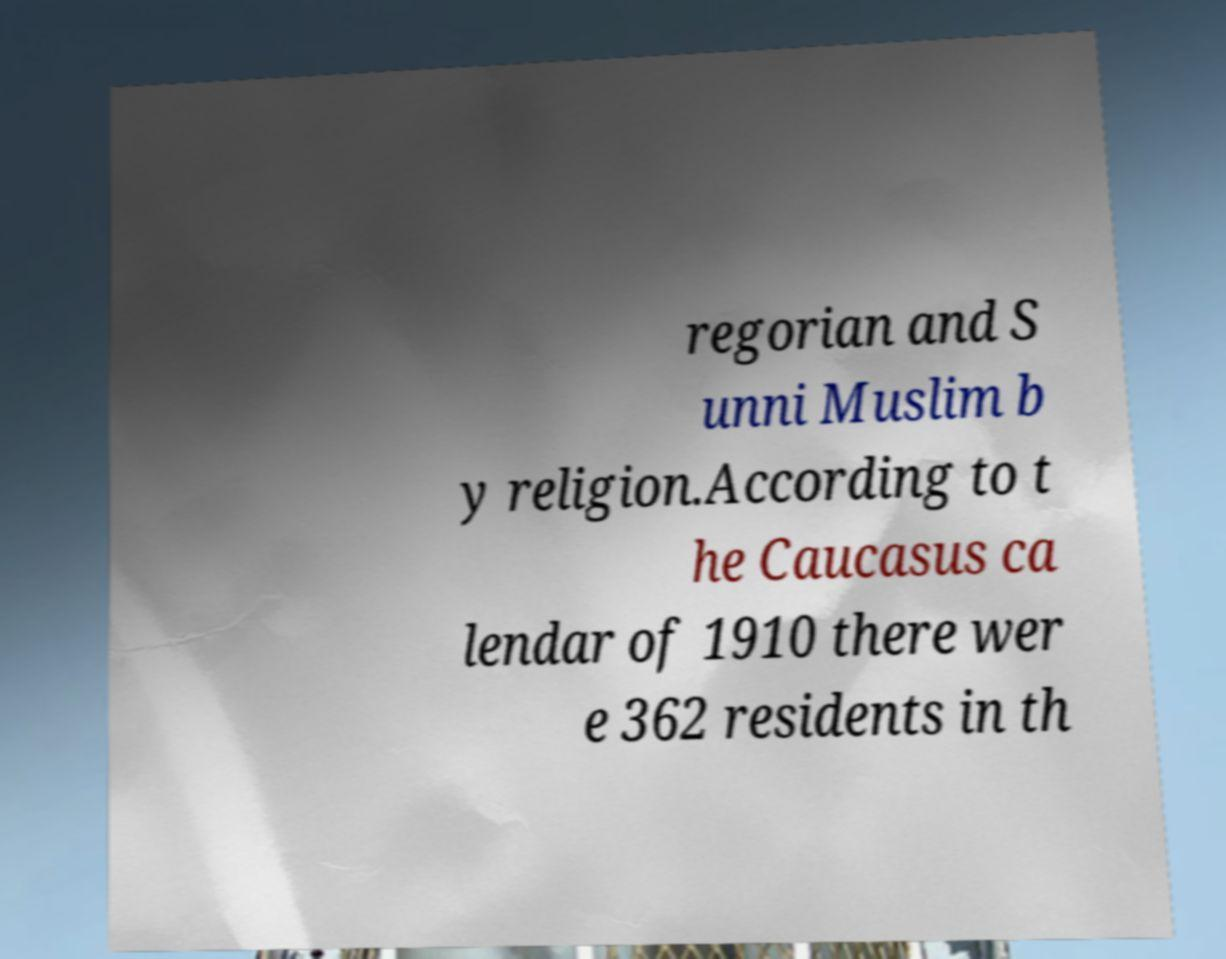Could you assist in decoding the text presented in this image and type it out clearly? regorian and S unni Muslim b y religion.According to t he Caucasus ca lendar of 1910 there wer e 362 residents in th 